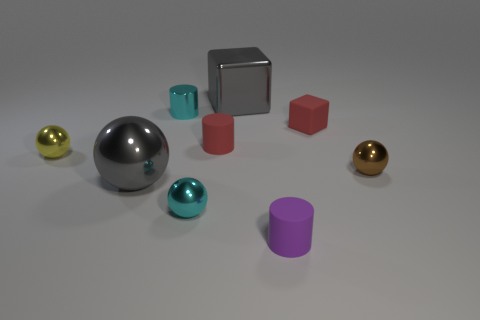Can you tell me the colors and shapes of the objects in the image? Certainly! In the image there are objects of various colors and shapes: two spheres (one silver and one gold), three cylinders (cyan, purple, and red), two cubes (both are red), and one silver box-shaped object. 